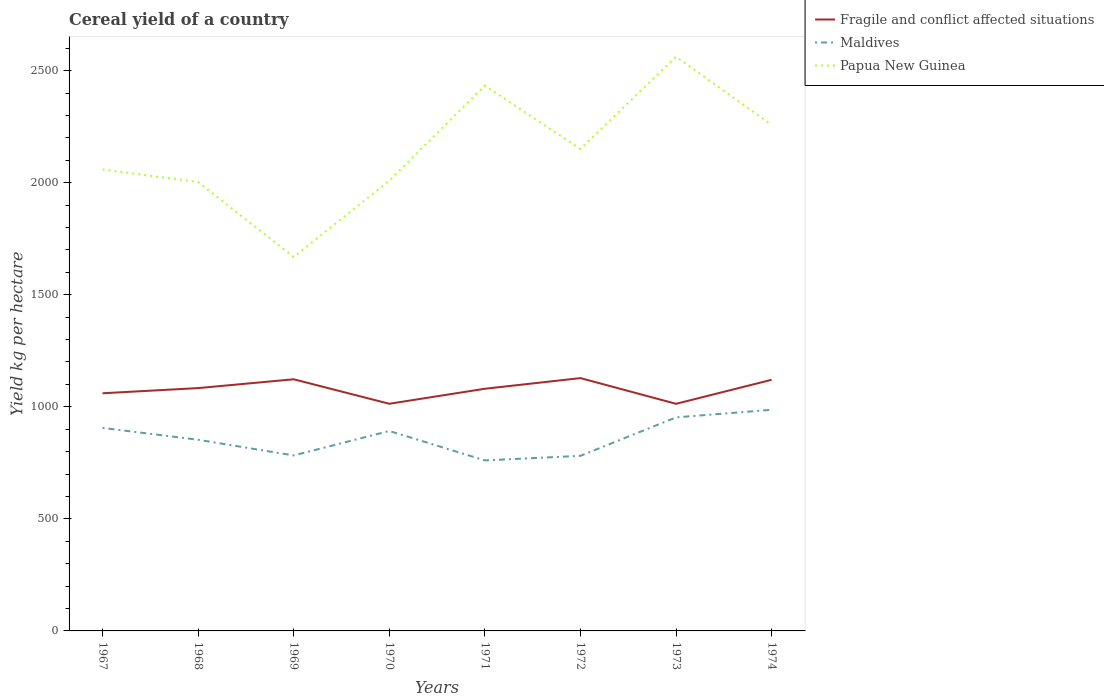Does the line corresponding to Papua New Guinea intersect with the line corresponding to Fragile and conflict affected situations?
Offer a very short reply. No. Across all years, what is the maximum total cereal yield in Papua New Guinea?
Give a very brief answer. 1668.64. In which year was the total cereal yield in Maldives maximum?
Keep it short and to the point. 1971. What is the total total cereal yield in Papua New Guinea in the graph?
Give a very brief answer. -128.69. What is the difference between the highest and the second highest total cereal yield in Maldives?
Keep it short and to the point. 225.92. How many years are there in the graph?
Give a very brief answer. 8. What is the difference between two consecutive major ticks on the Y-axis?
Offer a terse response. 500. Does the graph contain grids?
Give a very brief answer. No. How many legend labels are there?
Make the answer very short. 3. How are the legend labels stacked?
Make the answer very short. Vertical. What is the title of the graph?
Give a very brief answer. Cereal yield of a country. Does "Andorra" appear as one of the legend labels in the graph?
Give a very brief answer. No. What is the label or title of the Y-axis?
Give a very brief answer. Yield kg per hectare. What is the Yield kg per hectare in Fragile and conflict affected situations in 1967?
Offer a terse response. 1060.43. What is the Yield kg per hectare of Maldives in 1967?
Provide a short and direct response. 905.84. What is the Yield kg per hectare of Papua New Guinea in 1967?
Offer a very short reply. 2058.76. What is the Yield kg per hectare in Fragile and conflict affected situations in 1968?
Provide a short and direct response. 1083.5. What is the Yield kg per hectare of Maldives in 1968?
Offer a terse response. 852.94. What is the Yield kg per hectare in Papua New Guinea in 1968?
Your response must be concise. 2003.04. What is the Yield kg per hectare in Fragile and conflict affected situations in 1969?
Make the answer very short. 1122.87. What is the Yield kg per hectare in Maldives in 1969?
Your answer should be very brief. 783.02. What is the Yield kg per hectare of Papua New Guinea in 1969?
Your answer should be compact. 1668.64. What is the Yield kg per hectare of Fragile and conflict affected situations in 1970?
Provide a short and direct response. 1013.57. What is the Yield kg per hectare of Maldives in 1970?
Your answer should be compact. 892.19. What is the Yield kg per hectare of Papua New Guinea in 1970?
Make the answer very short. 2008.81. What is the Yield kg per hectare of Fragile and conflict affected situations in 1971?
Give a very brief answer. 1080.58. What is the Yield kg per hectare in Maldives in 1971?
Provide a short and direct response. 760.87. What is the Yield kg per hectare of Papua New Guinea in 1971?
Provide a succinct answer. 2433.28. What is the Yield kg per hectare of Fragile and conflict affected situations in 1972?
Keep it short and to the point. 1128.12. What is the Yield kg per hectare of Maldives in 1972?
Ensure brevity in your answer.  781.25. What is the Yield kg per hectare in Papua New Guinea in 1972?
Keep it short and to the point. 2150.62. What is the Yield kg per hectare in Fragile and conflict affected situations in 1973?
Offer a terse response. 1013.39. What is the Yield kg per hectare of Maldives in 1973?
Ensure brevity in your answer.  952.79. What is the Yield kg per hectare in Papua New Guinea in 1973?
Ensure brevity in your answer.  2561.97. What is the Yield kg per hectare in Fragile and conflict affected situations in 1974?
Offer a very short reply. 1120.53. What is the Yield kg per hectare in Maldives in 1974?
Give a very brief answer. 986.79. What is the Yield kg per hectare in Papua New Guinea in 1974?
Provide a short and direct response. 2257.98. Across all years, what is the maximum Yield kg per hectare of Fragile and conflict affected situations?
Keep it short and to the point. 1128.12. Across all years, what is the maximum Yield kg per hectare of Maldives?
Offer a terse response. 986.79. Across all years, what is the maximum Yield kg per hectare in Papua New Guinea?
Ensure brevity in your answer.  2561.97. Across all years, what is the minimum Yield kg per hectare of Fragile and conflict affected situations?
Your response must be concise. 1013.39. Across all years, what is the minimum Yield kg per hectare in Maldives?
Provide a short and direct response. 760.87. Across all years, what is the minimum Yield kg per hectare of Papua New Guinea?
Your answer should be compact. 1668.64. What is the total Yield kg per hectare of Fragile and conflict affected situations in the graph?
Offer a terse response. 8622.99. What is the total Yield kg per hectare of Maldives in the graph?
Give a very brief answer. 6915.71. What is the total Yield kg per hectare in Papua New Guinea in the graph?
Offer a terse response. 1.71e+04. What is the difference between the Yield kg per hectare in Fragile and conflict affected situations in 1967 and that in 1968?
Ensure brevity in your answer.  -23.07. What is the difference between the Yield kg per hectare in Maldives in 1967 and that in 1968?
Your answer should be compact. 52.9. What is the difference between the Yield kg per hectare of Papua New Guinea in 1967 and that in 1968?
Offer a terse response. 55.72. What is the difference between the Yield kg per hectare in Fragile and conflict affected situations in 1967 and that in 1969?
Provide a short and direct response. -62.44. What is the difference between the Yield kg per hectare in Maldives in 1967 and that in 1969?
Offer a very short reply. 122.83. What is the difference between the Yield kg per hectare of Papua New Guinea in 1967 and that in 1969?
Offer a very short reply. 390.12. What is the difference between the Yield kg per hectare of Fragile and conflict affected situations in 1967 and that in 1970?
Make the answer very short. 46.86. What is the difference between the Yield kg per hectare in Maldives in 1967 and that in 1970?
Ensure brevity in your answer.  13.65. What is the difference between the Yield kg per hectare of Papua New Guinea in 1967 and that in 1970?
Make the answer very short. 49.95. What is the difference between the Yield kg per hectare of Fragile and conflict affected situations in 1967 and that in 1971?
Make the answer very short. -20.15. What is the difference between the Yield kg per hectare in Maldives in 1967 and that in 1971?
Offer a terse response. 144.97. What is the difference between the Yield kg per hectare of Papua New Guinea in 1967 and that in 1971?
Keep it short and to the point. -374.52. What is the difference between the Yield kg per hectare in Fragile and conflict affected situations in 1967 and that in 1972?
Offer a terse response. -67.69. What is the difference between the Yield kg per hectare of Maldives in 1967 and that in 1972?
Offer a very short reply. 124.59. What is the difference between the Yield kg per hectare of Papua New Guinea in 1967 and that in 1972?
Provide a succinct answer. -91.86. What is the difference between the Yield kg per hectare of Fragile and conflict affected situations in 1967 and that in 1973?
Offer a terse response. 47.04. What is the difference between the Yield kg per hectare of Maldives in 1967 and that in 1973?
Provide a short and direct response. -46.95. What is the difference between the Yield kg per hectare of Papua New Guinea in 1967 and that in 1973?
Offer a very short reply. -503.21. What is the difference between the Yield kg per hectare in Fragile and conflict affected situations in 1967 and that in 1974?
Offer a very short reply. -60.1. What is the difference between the Yield kg per hectare of Maldives in 1967 and that in 1974?
Your answer should be compact. -80.95. What is the difference between the Yield kg per hectare of Papua New Guinea in 1967 and that in 1974?
Provide a succinct answer. -199.22. What is the difference between the Yield kg per hectare of Fragile and conflict affected situations in 1968 and that in 1969?
Make the answer very short. -39.37. What is the difference between the Yield kg per hectare of Maldives in 1968 and that in 1969?
Give a very brief answer. 69.92. What is the difference between the Yield kg per hectare in Papua New Guinea in 1968 and that in 1969?
Your answer should be very brief. 334.4. What is the difference between the Yield kg per hectare in Fragile and conflict affected situations in 1968 and that in 1970?
Ensure brevity in your answer.  69.93. What is the difference between the Yield kg per hectare of Maldives in 1968 and that in 1970?
Your answer should be compact. -39.25. What is the difference between the Yield kg per hectare of Papua New Guinea in 1968 and that in 1970?
Offer a very short reply. -5.77. What is the difference between the Yield kg per hectare of Fragile and conflict affected situations in 1968 and that in 1971?
Give a very brief answer. 2.92. What is the difference between the Yield kg per hectare in Maldives in 1968 and that in 1971?
Your answer should be very brief. 92.07. What is the difference between the Yield kg per hectare of Papua New Guinea in 1968 and that in 1971?
Your response must be concise. -430.24. What is the difference between the Yield kg per hectare of Fragile and conflict affected situations in 1968 and that in 1972?
Make the answer very short. -44.62. What is the difference between the Yield kg per hectare in Maldives in 1968 and that in 1972?
Your answer should be very brief. 71.69. What is the difference between the Yield kg per hectare of Papua New Guinea in 1968 and that in 1972?
Your response must be concise. -147.58. What is the difference between the Yield kg per hectare of Fragile and conflict affected situations in 1968 and that in 1973?
Offer a very short reply. 70.11. What is the difference between the Yield kg per hectare in Maldives in 1968 and that in 1973?
Your response must be concise. -99.85. What is the difference between the Yield kg per hectare in Papua New Guinea in 1968 and that in 1973?
Provide a succinct answer. -558.93. What is the difference between the Yield kg per hectare of Fragile and conflict affected situations in 1968 and that in 1974?
Your response must be concise. -37.03. What is the difference between the Yield kg per hectare of Maldives in 1968 and that in 1974?
Keep it short and to the point. -133.85. What is the difference between the Yield kg per hectare of Papua New Guinea in 1968 and that in 1974?
Make the answer very short. -254.94. What is the difference between the Yield kg per hectare in Fragile and conflict affected situations in 1969 and that in 1970?
Provide a short and direct response. 109.3. What is the difference between the Yield kg per hectare in Maldives in 1969 and that in 1970?
Provide a short and direct response. -109.17. What is the difference between the Yield kg per hectare of Papua New Guinea in 1969 and that in 1970?
Your response must be concise. -340.17. What is the difference between the Yield kg per hectare of Fragile and conflict affected situations in 1969 and that in 1971?
Make the answer very short. 42.28. What is the difference between the Yield kg per hectare of Maldives in 1969 and that in 1971?
Make the answer very short. 22.15. What is the difference between the Yield kg per hectare of Papua New Guinea in 1969 and that in 1971?
Offer a very short reply. -764.63. What is the difference between the Yield kg per hectare in Fragile and conflict affected situations in 1969 and that in 1972?
Provide a short and direct response. -5.25. What is the difference between the Yield kg per hectare in Maldives in 1969 and that in 1972?
Provide a short and direct response. 1.77. What is the difference between the Yield kg per hectare of Papua New Guinea in 1969 and that in 1972?
Give a very brief answer. -481.98. What is the difference between the Yield kg per hectare in Fragile and conflict affected situations in 1969 and that in 1973?
Your response must be concise. 109.48. What is the difference between the Yield kg per hectare in Maldives in 1969 and that in 1973?
Provide a succinct answer. -169.78. What is the difference between the Yield kg per hectare of Papua New Guinea in 1969 and that in 1973?
Ensure brevity in your answer.  -893.33. What is the difference between the Yield kg per hectare of Fragile and conflict affected situations in 1969 and that in 1974?
Give a very brief answer. 2.33. What is the difference between the Yield kg per hectare of Maldives in 1969 and that in 1974?
Offer a terse response. -203.78. What is the difference between the Yield kg per hectare of Papua New Guinea in 1969 and that in 1974?
Offer a very short reply. -589.33. What is the difference between the Yield kg per hectare in Fragile and conflict affected situations in 1970 and that in 1971?
Make the answer very short. -67.01. What is the difference between the Yield kg per hectare in Maldives in 1970 and that in 1971?
Provide a short and direct response. 131.32. What is the difference between the Yield kg per hectare in Papua New Guinea in 1970 and that in 1971?
Your response must be concise. -424.46. What is the difference between the Yield kg per hectare in Fragile and conflict affected situations in 1970 and that in 1972?
Keep it short and to the point. -114.55. What is the difference between the Yield kg per hectare of Maldives in 1970 and that in 1972?
Your response must be concise. 110.94. What is the difference between the Yield kg per hectare in Papua New Guinea in 1970 and that in 1972?
Provide a succinct answer. -141.81. What is the difference between the Yield kg per hectare in Fragile and conflict affected situations in 1970 and that in 1973?
Offer a terse response. 0.18. What is the difference between the Yield kg per hectare of Maldives in 1970 and that in 1973?
Keep it short and to the point. -60.6. What is the difference between the Yield kg per hectare in Papua New Guinea in 1970 and that in 1973?
Your answer should be compact. -553.15. What is the difference between the Yield kg per hectare in Fragile and conflict affected situations in 1970 and that in 1974?
Offer a terse response. -106.96. What is the difference between the Yield kg per hectare of Maldives in 1970 and that in 1974?
Your answer should be compact. -94.6. What is the difference between the Yield kg per hectare of Papua New Guinea in 1970 and that in 1974?
Your answer should be very brief. -249.16. What is the difference between the Yield kg per hectare of Fragile and conflict affected situations in 1971 and that in 1972?
Give a very brief answer. -47.54. What is the difference between the Yield kg per hectare of Maldives in 1971 and that in 1972?
Offer a very short reply. -20.38. What is the difference between the Yield kg per hectare in Papua New Guinea in 1971 and that in 1972?
Provide a short and direct response. 282.66. What is the difference between the Yield kg per hectare of Fragile and conflict affected situations in 1971 and that in 1973?
Offer a terse response. 67.2. What is the difference between the Yield kg per hectare of Maldives in 1971 and that in 1973?
Your response must be concise. -191.93. What is the difference between the Yield kg per hectare of Papua New Guinea in 1971 and that in 1973?
Offer a terse response. -128.69. What is the difference between the Yield kg per hectare of Fragile and conflict affected situations in 1971 and that in 1974?
Ensure brevity in your answer.  -39.95. What is the difference between the Yield kg per hectare in Maldives in 1971 and that in 1974?
Make the answer very short. -225.93. What is the difference between the Yield kg per hectare in Papua New Guinea in 1971 and that in 1974?
Make the answer very short. 175.3. What is the difference between the Yield kg per hectare in Fragile and conflict affected situations in 1972 and that in 1973?
Your response must be concise. 114.73. What is the difference between the Yield kg per hectare in Maldives in 1972 and that in 1973?
Your response must be concise. -171.54. What is the difference between the Yield kg per hectare of Papua New Guinea in 1972 and that in 1973?
Make the answer very short. -411.35. What is the difference between the Yield kg per hectare of Fragile and conflict affected situations in 1972 and that in 1974?
Offer a very short reply. 7.59. What is the difference between the Yield kg per hectare in Maldives in 1972 and that in 1974?
Offer a very short reply. -205.54. What is the difference between the Yield kg per hectare in Papua New Guinea in 1972 and that in 1974?
Your response must be concise. -107.36. What is the difference between the Yield kg per hectare of Fragile and conflict affected situations in 1973 and that in 1974?
Give a very brief answer. -107.15. What is the difference between the Yield kg per hectare of Maldives in 1973 and that in 1974?
Your answer should be compact. -34. What is the difference between the Yield kg per hectare in Papua New Guinea in 1973 and that in 1974?
Your answer should be compact. 303.99. What is the difference between the Yield kg per hectare in Fragile and conflict affected situations in 1967 and the Yield kg per hectare in Maldives in 1968?
Make the answer very short. 207.49. What is the difference between the Yield kg per hectare in Fragile and conflict affected situations in 1967 and the Yield kg per hectare in Papua New Guinea in 1968?
Ensure brevity in your answer.  -942.61. What is the difference between the Yield kg per hectare of Maldives in 1967 and the Yield kg per hectare of Papua New Guinea in 1968?
Your answer should be compact. -1097.2. What is the difference between the Yield kg per hectare of Fragile and conflict affected situations in 1967 and the Yield kg per hectare of Maldives in 1969?
Give a very brief answer. 277.41. What is the difference between the Yield kg per hectare in Fragile and conflict affected situations in 1967 and the Yield kg per hectare in Papua New Guinea in 1969?
Provide a succinct answer. -608.21. What is the difference between the Yield kg per hectare of Maldives in 1967 and the Yield kg per hectare of Papua New Guinea in 1969?
Offer a very short reply. -762.8. What is the difference between the Yield kg per hectare in Fragile and conflict affected situations in 1967 and the Yield kg per hectare in Maldives in 1970?
Your answer should be very brief. 168.24. What is the difference between the Yield kg per hectare in Fragile and conflict affected situations in 1967 and the Yield kg per hectare in Papua New Guinea in 1970?
Provide a short and direct response. -948.39. What is the difference between the Yield kg per hectare in Maldives in 1967 and the Yield kg per hectare in Papua New Guinea in 1970?
Offer a very short reply. -1102.97. What is the difference between the Yield kg per hectare in Fragile and conflict affected situations in 1967 and the Yield kg per hectare in Maldives in 1971?
Provide a short and direct response. 299.56. What is the difference between the Yield kg per hectare in Fragile and conflict affected situations in 1967 and the Yield kg per hectare in Papua New Guinea in 1971?
Provide a succinct answer. -1372.85. What is the difference between the Yield kg per hectare of Maldives in 1967 and the Yield kg per hectare of Papua New Guinea in 1971?
Offer a very short reply. -1527.43. What is the difference between the Yield kg per hectare in Fragile and conflict affected situations in 1967 and the Yield kg per hectare in Maldives in 1972?
Offer a very short reply. 279.18. What is the difference between the Yield kg per hectare in Fragile and conflict affected situations in 1967 and the Yield kg per hectare in Papua New Guinea in 1972?
Your answer should be very brief. -1090.19. What is the difference between the Yield kg per hectare of Maldives in 1967 and the Yield kg per hectare of Papua New Guinea in 1972?
Ensure brevity in your answer.  -1244.78. What is the difference between the Yield kg per hectare of Fragile and conflict affected situations in 1967 and the Yield kg per hectare of Maldives in 1973?
Provide a short and direct response. 107.63. What is the difference between the Yield kg per hectare of Fragile and conflict affected situations in 1967 and the Yield kg per hectare of Papua New Guinea in 1973?
Make the answer very short. -1501.54. What is the difference between the Yield kg per hectare of Maldives in 1967 and the Yield kg per hectare of Papua New Guinea in 1973?
Provide a short and direct response. -1656.12. What is the difference between the Yield kg per hectare of Fragile and conflict affected situations in 1967 and the Yield kg per hectare of Maldives in 1974?
Keep it short and to the point. 73.63. What is the difference between the Yield kg per hectare in Fragile and conflict affected situations in 1967 and the Yield kg per hectare in Papua New Guinea in 1974?
Offer a very short reply. -1197.55. What is the difference between the Yield kg per hectare in Maldives in 1967 and the Yield kg per hectare in Papua New Guinea in 1974?
Keep it short and to the point. -1352.13. What is the difference between the Yield kg per hectare in Fragile and conflict affected situations in 1968 and the Yield kg per hectare in Maldives in 1969?
Offer a very short reply. 300.48. What is the difference between the Yield kg per hectare of Fragile and conflict affected situations in 1968 and the Yield kg per hectare of Papua New Guinea in 1969?
Ensure brevity in your answer.  -585.14. What is the difference between the Yield kg per hectare in Maldives in 1968 and the Yield kg per hectare in Papua New Guinea in 1969?
Your answer should be compact. -815.7. What is the difference between the Yield kg per hectare of Fragile and conflict affected situations in 1968 and the Yield kg per hectare of Maldives in 1970?
Your answer should be compact. 191.31. What is the difference between the Yield kg per hectare in Fragile and conflict affected situations in 1968 and the Yield kg per hectare in Papua New Guinea in 1970?
Ensure brevity in your answer.  -925.31. What is the difference between the Yield kg per hectare of Maldives in 1968 and the Yield kg per hectare of Papua New Guinea in 1970?
Your answer should be compact. -1155.87. What is the difference between the Yield kg per hectare in Fragile and conflict affected situations in 1968 and the Yield kg per hectare in Maldives in 1971?
Make the answer very short. 322.63. What is the difference between the Yield kg per hectare of Fragile and conflict affected situations in 1968 and the Yield kg per hectare of Papua New Guinea in 1971?
Your response must be concise. -1349.78. What is the difference between the Yield kg per hectare in Maldives in 1968 and the Yield kg per hectare in Papua New Guinea in 1971?
Ensure brevity in your answer.  -1580.34. What is the difference between the Yield kg per hectare of Fragile and conflict affected situations in 1968 and the Yield kg per hectare of Maldives in 1972?
Your answer should be compact. 302.25. What is the difference between the Yield kg per hectare in Fragile and conflict affected situations in 1968 and the Yield kg per hectare in Papua New Guinea in 1972?
Provide a succinct answer. -1067.12. What is the difference between the Yield kg per hectare in Maldives in 1968 and the Yield kg per hectare in Papua New Guinea in 1972?
Your answer should be compact. -1297.68. What is the difference between the Yield kg per hectare in Fragile and conflict affected situations in 1968 and the Yield kg per hectare in Maldives in 1973?
Your response must be concise. 130.71. What is the difference between the Yield kg per hectare in Fragile and conflict affected situations in 1968 and the Yield kg per hectare in Papua New Guinea in 1973?
Your answer should be very brief. -1478.47. What is the difference between the Yield kg per hectare in Maldives in 1968 and the Yield kg per hectare in Papua New Guinea in 1973?
Provide a short and direct response. -1709.03. What is the difference between the Yield kg per hectare of Fragile and conflict affected situations in 1968 and the Yield kg per hectare of Maldives in 1974?
Offer a terse response. 96.71. What is the difference between the Yield kg per hectare of Fragile and conflict affected situations in 1968 and the Yield kg per hectare of Papua New Guinea in 1974?
Ensure brevity in your answer.  -1174.47. What is the difference between the Yield kg per hectare in Maldives in 1968 and the Yield kg per hectare in Papua New Guinea in 1974?
Offer a terse response. -1405.04. What is the difference between the Yield kg per hectare in Fragile and conflict affected situations in 1969 and the Yield kg per hectare in Maldives in 1970?
Give a very brief answer. 230.67. What is the difference between the Yield kg per hectare in Fragile and conflict affected situations in 1969 and the Yield kg per hectare in Papua New Guinea in 1970?
Your response must be concise. -885.95. What is the difference between the Yield kg per hectare in Maldives in 1969 and the Yield kg per hectare in Papua New Guinea in 1970?
Provide a short and direct response. -1225.8. What is the difference between the Yield kg per hectare in Fragile and conflict affected situations in 1969 and the Yield kg per hectare in Maldives in 1971?
Provide a succinct answer. 362. What is the difference between the Yield kg per hectare in Fragile and conflict affected situations in 1969 and the Yield kg per hectare in Papua New Guinea in 1971?
Keep it short and to the point. -1310.41. What is the difference between the Yield kg per hectare in Maldives in 1969 and the Yield kg per hectare in Papua New Guinea in 1971?
Offer a very short reply. -1650.26. What is the difference between the Yield kg per hectare in Fragile and conflict affected situations in 1969 and the Yield kg per hectare in Maldives in 1972?
Your response must be concise. 341.62. What is the difference between the Yield kg per hectare in Fragile and conflict affected situations in 1969 and the Yield kg per hectare in Papua New Guinea in 1972?
Make the answer very short. -1027.75. What is the difference between the Yield kg per hectare in Maldives in 1969 and the Yield kg per hectare in Papua New Guinea in 1972?
Offer a very short reply. -1367.6. What is the difference between the Yield kg per hectare in Fragile and conflict affected situations in 1969 and the Yield kg per hectare in Maldives in 1973?
Offer a very short reply. 170.07. What is the difference between the Yield kg per hectare in Fragile and conflict affected situations in 1969 and the Yield kg per hectare in Papua New Guinea in 1973?
Provide a short and direct response. -1439.1. What is the difference between the Yield kg per hectare of Maldives in 1969 and the Yield kg per hectare of Papua New Guinea in 1973?
Provide a short and direct response. -1778.95. What is the difference between the Yield kg per hectare in Fragile and conflict affected situations in 1969 and the Yield kg per hectare in Maldives in 1974?
Your answer should be very brief. 136.07. What is the difference between the Yield kg per hectare in Fragile and conflict affected situations in 1969 and the Yield kg per hectare in Papua New Guinea in 1974?
Offer a terse response. -1135.11. What is the difference between the Yield kg per hectare in Maldives in 1969 and the Yield kg per hectare in Papua New Guinea in 1974?
Your answer should be compact. -1474.96. What is the difference between the Yield kg per hectare of Fragile and conflict affected situations in 1970 and the Yield kg per hectare of Maldives in 1971?
Provide a short and direct response. 252.7. What is the difference between the Yield kg per hectare of Fragile and conflict affected situations in 1970 and the Yield kg per hectare of Papua New Guinea in 1971?
Give a very brief answer. -1419.71. What is the difference between the Yield kg per hectare of Maldives in 1970 and the Yield kg per hectare of Papua New Guinea in 1971?
Make the answer very short. -1541.08. What is the difference between the Yield kg per hectare of Fragile and conflict affected situations in 1970 and the Yield kg per hectare of Maldives in 1972?
Ensure brevity in your answer.  232.32. What is the difference between the Yield kg per hectare of Fragile and conflict affected situations in 1970 and the Yield kg per hectare of Papua New Guinea in 1972?
Your answer should be very brief. -1137.05. What is the difference between the Yield kg per hectare in Maldives in 1970 and the Yield kg per hectare in Papua New Guinea in 1972?
Provide a short and direct response. -1258.43. What is the difference between the Yield kg per hectare in Fragile and conflict affected situations in 1970 and the Yield kg per hectare in Maldives in 1973?
Your answer should be compact. 60.77. What is the difference between the Yield kg per hectare of Fragile and conflict affected situations in 1970 and the Yield kg per hectare of Papua New Guinea in 1973?
Make the answer very short. -1548.4. What is the difference between the Yield kg per hectare of Maldives in 1970 and the Yield kg per hectare of Papua New Guinea in 1973?
Make the answer very short. -1669.78. What is the difference between the Yield kg per hectare of Fragile and conflict affected situations in 1970 and the Yield kg per hectare of Maldives in 1974?
Offer a terse response. 26.77. What is the difference between the Yield kg per hectare of Fragile and conflict affected situations in 1970 and the Yield kg per hectare of Papua New Guinea in 1974?
Offer a very short reply. -1244.41. What is the difference between the Yield kg per hectare in Maldives in 1970 and the Yield kg per hectare in Papua New Guinea in 1974?
Your response must be concise. -1365.78. What is the difference between the Yield kg per hectare of Fragile and conflict affected situations in 1971 and the Yield kg per hectare of Maldives in 1972?
Ensure brevity in your answer.  299.33. What is the difference between the Yield kg per hectare in Fragile and conflict affected situations in 1971 and the Yield kg per hectare in Papua New Guinea in 1972?
Make the answer very short. -1070.04. What is the difference between the Yield kg per hectare of Maldives in 1971 and the Yield kg per hectare of Papua New Guinea in 1972?
Offer a very short reply. -1389.75. What is the difference between the Yield kg per hectare in Fragile and conflict affected situations in 1971 and the Yield kg per hectare in Maldives in 1973?
Give a very brief answer. 127.79. What is the difference between the Yield kg per hectare of Fragile and conflict affected situations in 1971 and the Yield kg per hectare of Papua New Guinea in 1973?
Keep it short and to the point. -1481.38. What is the difference between the Yield kg per hectare of Maldives in 1971 and the Yield kg per hectare of Papua New Guinea in 1973?
Make the answer very short. -1801.1. What is the difference between the Yield kg per hectare of Fragile and conflict affected situations in 1971 and the Yield kg per hectare of Maldives in 1974?
Provide a short and direct response. 93.79. What is the difference between the Yield kg per hectare of Fragile and conflict affected situations in 1971 and the Yield kg per hectare of Papua New Guinea in 1974?
Offer a terse response. -1177.39. What is the difference between the Yield kg per hectare in Maldives in 1971 and the Yield kg per hectare in Papua New Guinea in 1974?
Your answer should be very brief. -1497.11. What is the difference between the Yield kg per hectare of Fragile and conflict affected situations in 1972 and the Yield kg per hectare of Maldives in 1973?
Your response must be concise. 175.32. What is the difference between the Yield kg per hectare in Fragile and conflict affected situations in 1972 and the Yield kg per hectare in Papua New Guinea in 1973?
Give a very brief answer. -1433.85. What is the difference between the Yield kg per hectare in Maldives in 1972 and the Yield kg per hectare in Papua New Guinea in 1973?
Ensure brevity in your answer.  -1780.72. What is the difference between the Yield kg per hectare of Fragile and conflict affected situations in 1972 and the Yield kg per hectare of Maldives in 1974?
Your answer should be very brief. 141.32. What is the difference between the Yield kg per hectare in Fragile and conflict affected situations in 1972 and the Yield kg per hectare in Papua New Guinea in 1974?
Offer a very short reply. -1129.86. What is the difference between the Yield kg per hectare in Maldives in 1972 and the Yield kg per hectare in Papua New Guinea in 1974?
Keep it short and to the point. -1476.73. What is the difference between the Yield kg per hectare of Fragile and conflict affected situations in 1973 and the Yield kg per hectare of Maldives in 1974?
Give a very brief answer. 26.59. What is the difference between the Yield kg per hectare of Fragile and conflict affected situations in 1973 and the Yield kg per hectare of Papua New Guinea in 1974?
Offer a terse response. -1244.59. What is the difference between the Yield kg per hectare in Maldives in 1973 and the Yield kg per hectare in Papua New Guinea in 1974?
Provide a short and direct response. -1305.18. What is the average Yield kg per hectare in Fragile and conflict affected situations per year?
Your answer should be compact. 1077.87. What is the average Yield kg per hectare in Maldives per year?
Your answer should be compact. 864.46. What is the average Yield kg per hectare in Papua New Guinea per year?
Your response must be concise. 2142.89. In the year 1967, what is the difference between the Yield kg per hectare in Fragile and conflict affected situations and Yield kg per hectare in Maldives?
Provide a succinct answer. 154.58. In the year 1967, what is the difference between the Yield kg per hectare in Fragile and conflict affected situations and Yield kg per hectare in Papua New Guinea?
Your response must be concise. -998.33. In the year 1967, what is the difference between the Yield kg per hectare of Maldives and Yield kg per hectare of Papua New Guinea?
Provide a short and direct response. -1152.92. In the year 1968, what is the difference between the Yield kg per hectare of Fragile and conflict affected situations and Yield kg per hectare of Maldives?
Make the answer very short. 230.56. In the year 1968, what is the difference between the Yield kg per hectare in Fragile and conflict affected situations and Yield kg per hectare in Papua New Guinea?
Your answer should be compact. -919.54. In the year 1968, what is the difference between the Yield kg per hectare of Maldives and Yield kg per hectare of Papua New Guinea?
Your answer should be very brief. -1150.1. In the year 1969, what is the difference between the Yield kg per hectare in Fragile and conflict affected situations and Yield kg per hectare in Maldives?
Your answer should be very brief. 339.85. In the year 1969, what is the difference between the Yield kg per hectare in Fragile and conflict affected situations and Yield kg per hectare in Papua New Guinea?
Give a very brief answer. -545.78. In the year 1969, what is the difference between the Yield kg per hectare of Maldives and Yield kg per hectare of Papua New Guinea?
Offer a very short reply. -885.62. In the year 1970, what is the difference between the Yield kg per hectare in Fragile and conflict affected situations and Yield kg per hectare in Maldives?
Offer a terse response. 121.38. In the year 1970, what is the difference between the Yield kg per hectare of Fragile and conflict affected situations and Yield kg per hectare of Papua New Guinea?
Ensure brevity in your answer.  -995.25. In the year 1970, what is the difference between the Yield kg per hectare of Maldives and Yield kg per hectare of Papua New Guinea?
Your answer should be very brief. -1116.62. In the year 1971, what is the difference between the Yield kg per hectare in Fragile and conflict affected situations and Yield kg per hectare in Maldives?
Your answer should be very brief. 319.71. In the year 1971, what is the difference between the Yield kg per hectare in Fragile and conflict affected situations and Yield kg per hectare in Papua New Guinea?
Provide a succinct answer. -1352.69. In the year 1971, what is the difference between the Yield kg per hectare in Maldives and Yield kg per hectare in Papua New Guinea?
Keep it short and to the point. -1672.41. In the year 1972, what is the difference between the Yield kg per hectare of Fragile and conflict affected situations and Yield kg per hectare of Maldives?
Give a very brief answer. 346.87. In the year 1972, what is the difference between the Yield kg per hectare in Fragile and conflict affected situations and Yield kg per hectare in Papua New Guinea?
Offer a terse response. -1022.5. In the year 1972, what is the difference between the Yield kg per hectare in Maldives and Yield kg per hectare in Papua New Guinea?
Provide a succinct answer. -1369.37. In the year 1973, what is the difference between the Yield kg per hectare in Fragile and conflict affected situations and Yield kg per hectare in Maldives?
Your response must be concise. 60.59. In the year 1973, what is the difference between the Yield kg per hectare in Fragile and conflict affected situations and Yield kg per hectare in Papua New Guinea?
Your answer should be very brief. -1548.58. In the year 1973, what is the difference between the Yield kg per hectare of Maldives and Yield kg per hectare of Papua New Guinea?
Give a very brief answer. -1609.17. In the year 1974, what is the difference between the Yield kg per hectare of Fragile and conflict affected situations and Yield kg per hectare of Maldives?
Ensure brevity in your answer.  133.74. In the year 1974, what is the difference between the Yield kg per hectare of Fragile and conflict affected situations and Yield kg per hectare of Papua New Guinea?
Give a very brief answer. -1137.44. In the year 1974, what is the difference between the Yield kg per hectare of Maldives and Yield kg per hectare of Papua New Guinea?
Give a very brief answer. -1271.18. What is the ratio of the Yield kg per hectare of Fragile and conflict affected situations in 1967 to that in 1968?
Provide a short and direct response. 0.98. What is the ratio of the Yield kg per hectare in Maldives in 1967 to that in 1968?
Ensure brevity in your answer.  1.06. What is the ratio of the Yield kg per hectare of Papua New Guinea in 1967 to that in 1968?
Your response must be concise. 1.03. What is the ratio of the Yield kg per hectare of Fragile and conflict affected situations in 1967 to that in 1969?
Offer a very short reply. 0.94. What is the ratio of the Yield kg per hectare in Maldives in 1967 to that in 1969?
Your answer should be very brief. 1.16. What is the ratio of the Yield kg per hectare in Papua New Guinea in 1967 to that in 1969?
Ensure brevity in your answer.  1.23. What is the ratio of the Yield kg per hectare in Fragile and conflict affected situations in 1967 to that in 1970?
Your answer should be very brief. 1.05. What is the ratio of the Yield kg per hectare in Maldives in 1967 to that in 1970?
Keep it short and to the point. 1.02. What is the ratio of the Yield kg per hectare of Papua New Guinea in 1967 to that in 1970?
Your response must be concise. 1.02. What is the ratio of the Yield kg per hectare in Fragile and conflict affected situations in 1967 to that in 1971?
Provide a succinct answer. 0.98. What is the ratio of the Yield kg per hectare of Maldives in 1967 to that in 1971?
Provide a short and direct response. 1.19. What is the ratio of the Yield kg per hectare in Papua New Guinea in 1967 to that in 1971?
Give a very brief answer. 0.85. What is the ratio of the Yield kg per hectare in Maldives in 1967 to that in 1972?
Ensure brevity in your answer.  1.16. What is the ratio of the Yield kg per hectare in Papua New Guinea in 1967 to that in 1972?
Provide a short and direct response. 0.96. What is the ratio of the Yield kg per hectare in Fragile and conflict affected situations in 1967 to that in 1973?
Make the answer very short. 1.05. What is the ratio of the Yield kg per hectare in Maldives in 1967 to that in 1973?
Your response must be concise. 0.95. What is the ratio of the Yield kg per hectare in Papua New Guinea in 1967 to that in 1973?
Offer a terse response. 0.8. What is the ratio of the Yield kg per hectare in Fragile and conflict affected situations in 1967 to that in 1974?
Offer a very short reply. 0.95. What is the ratio of the Yield kg per hectare in Maldives in 1967 to that in 1974?
Ensure brevity in your answer.  0.92. What is the ratio of the Yield kg per hectare of Papua New Guinea in 1967 to that in 1974?
Offer a terse response. 0.91. What is the ratio of the Yield kg per hectare of Fragile and conflict affected situations in 1968 to that in 1969?
Offer a very short reply. 0.96. What is the ratio of the Yield kg per hectare in Maldives in 1968 to that in 1969?
Provide a short and direct response. 1.09. What is the ratio of the Yield kg per hectare of Papua New Guinea in 1968 to that in 1969?
Offer a terse response. 1.2. What is the ratio of the Yield kg per hectare in Fragile and conflict affected situations in 1968 to that in 1970?
Make the answer very short. 1.07. What is the ratio of the Yield kg per hectare of Maldives in 1968 to that in 1970?
Provide a succinct answer. 0.96. What is the ratio of the Yield kg per hectare of Papua New Guinea in 1968 to that in 1970?
Keep it short and to the point. 1. What is the ratio of the Yield kg per hectare of Fragile and conflict affected situations in 1968 to that in 1971?
Ensure brevity in your answer.  1. What is the ratio of the Yield kg per hectare of Maldives in 1968 to that in 1971?
Your response must be concise. 1.12. What is the ratio of the Yield kg per hectare of Papua New Guinea in 1968 to that in 1971?
Your response must be concise. 0.82. What is the ratio of the Yield kg per hectare of Fragile and conflict affected situations in 1968 to that in 1972?
Provide a short and direct response. 0.96. What is the ratio of the Yield kg per hectare in Maldives in 1968 to that in 1972?
Provide a short and direct response. 1.09. What is the ratio of the Yield kg per hectare in Papua New Guinea in 1968 to that in 1972?
Make the answer very short. 0.93. What is the ratio of the Yield kg per hectare in Fragile and conflict affected situations in 1968 to that in 1973?
Make the answer very short. 1.07. What is the ratio of the Yield kg per hectare in Maldives in 1968 to that in 1973?
Your answer should be very brief. 0.9. What is the ratio of the Yield kg per hectare in Papua New Guinea in 1968 to that in 1973?
Give a very brief answer. 0.78. What is the ratio of the Yield kg per hectare of Fragile and conflict affected situations in 1968 to that in 1974?
Provide a succinct answer. 0.97. What is the ratio of the Yield kg per hectare of Maldives in 1968 to that in 1974?
Keep it short and to the point. 0.86. What is the ratio of the Yield kg per hectare of Papua New Guinea in 1968 to that in 1974?
Your answer should be compact. 0.89. What is the ratio of the Yield kg per hectare of Fragile and conflict affected situations in 1969 to that in 1970?
Provide a short and direct response. 1.11. What is the ratio of the Yield kg per hectare in Maldives in 1969 to that in 1970?
Your response must be concise. 0.88. What is the ratio of the Yield kg per hectare in Papua New Guinea in 1969 to that in 1970?
Your answer should be compact. 0.83. What is the ratio of the Yield kg per hectare of Fragile and conflict affected situations in 1969 to that in 1971?
Ensure brevity in your answer.  1.04. What is the ratio of the Yield kg per hectare of Maldives in 1969 to that in 1971?
Keep it short and to the point. 1.03. What is the ratio of the Yield kg per hectare in Papua New Guinea in 1969 to that in 1971?
Offer a terse response. 0.69. What is the ratio of the Yield kg per hectare in Maldives in 1969 to that in 1972?
Ensure brevity in your answer.  1. What is the ratio of the Yield kg per hectare in Papua New Guinea in 1969 to that in 1972?
Provide a short and direct response. 0.78. What is the ratio of the Yield kg per hectare of Fragile and conflict affected situations in 1969 to that in 1973?
Provide a short and direct response. 1.11. What is the ratio of the Yield kg per hectare in Maldives in 1969 to that in 1973?
Provide a succinct answer. 0.82. What is the ratio of the Yield kg per hectare in Papua New Guinea in 1969 to that in 1973?
Give a very brief answer. 0.65. What is the ratio of the Yield kg per hectare of Fragile and conflict affected situations in 1969 to that in 1974?
Your answer should be very brief. 1. What is the ratio of the Yield kg per hectare of Maldives in 1969 to that in 1974?
Give a very brief answer. 0.79. What is the ratio of the Yield kg per hectare in Papua New Guinea in 1969 to that in 1974?
Your response must be concise. 0.74. What is the ratio of the Yield kg per hectare of Fragile and conflict affected situations in 1970 to that in 1971?
Your answer should be very brief. 0.94. What is the ratio of the Yield kg per hectare of Maldives in 1970 to that in 1971?
Provide a succinct answer. 1.17. What is the ratio of the Yield kg per hectare in Papua New Guinea in 1970 to that in 1971?
Offer a terse response. 0.83. What is the ratio of the Yield kg per hectare in Fragile and conflict affected situations in 1970 to that in 1972?
Your response must be concise. 0.9. What is the ratio of the Yield kg per hectare of Maldives in 1970 to that in 1972?
Offer a terse response. 1.14. What is the ratio of the Yield kg per hectare of Papua New Guinea in 1970 to that in 1972?
Offer a terse response. 0.93. What is the ratio of the Yield kg per hectare in Maldives in 1970 to that in 1973?
Ensure brevity in your answer.  0.94. What is the ratio of the Yield kg per hectare of Papua New Guinea in 1970 to that in 1973?
Offer a terse response. 0.78. What is the ratio of the Yield kg per hectare of Fragile and conflict affected situations in 1970 to that in 1974?
Offer a very short reply. 0.9. What is the ratio of the Yield kg per hectare of Maldives in 1970 to that in 1974?
Your answer should be very brief. 0.9. What is the ratio of the Yield kg per hectare in Papua New Guinea in 1970 to that in 1974?
Ensure brevity in your answer.  0.89. What is the ratio of the Yield kg per hectare in Fragile and conflict affected situations in 1971 to that in 1972?
Keep it short and to the point. 0.96. What is the ratio of the Yield kg per hectare of Maldives in 1971 to that in 1972?
Provide a succinct answer. 0.97. What is the ratio of the Yield kg per hectare in Papua New Guinea in 1971 to that in 1972?
Keep it short and to the point. 1.13. What is the ratio of the Yield kg per hectare in Fragile and conflict affected situations in 1971 to that in 1973?
Give a very brief answer. 1.07. What is the ratio of the Yield kg per hectare in Maldives in 1971 to that in 1973?
Your answer should be compact. 0.8. What is the ratio of the Yield kg per hectare in Papua New Guinea in 1971 to that in 1973?
Offer a terse response. 0.95. What is the ratio of the Yield kg per hectare in Fragile and conflict affected situations in 1971 to that in 1974?
Give a very brief answer. 0.96. What is the ratio of the Yield kg per hectare of Maldives in 1971 to that in 1974?
Provide a succinct answer. 0.77. What is the ratio of the Yield kg per hectare of Papua New Guinea in 1971 to that in 1974?
Give a very brief answer. 1.08. What is the ratio of the Yield kg per hectare of Fragile and conflict affected situations in 1972 to that in 1973?
Keep it short and to the point. 1.11. What is the ratio of the Yield kg per hectare of Maldives in 1972 to that in 1973?
Your response must be concise. 0.82. What is the ratio of the Yield kg per hectare of Papua New Guinea in 1972 to that in 1973?
Ensure brevity in your answer.  0.84. What is the ratio of the Yield kg per hectare in Fragile and conflict affected situations in 1972 to that in 1974?
Provide a succinct answer. 1.01. What is the ratio of the Yield kg per hectare of Maldives in 1972 to that in 1974?
Make the answer very short. 0.79. What is the ratio of the Yield kg per hectare of Papua New Guinea in 1972 to that in 1974?
Provide a succinct answer. 0.95. What is the ratio of the Yield kg per hectare of Fragile and conflict affected situations in 1973 to that in 1974?
Make the answer very short. 0.9. What is the ratio of the Yield kg per hectare in Maldives in 1973 to that in 1974?
Your response must be concise. 0.97. What is the ratio of the Yield kg per hectare in Papua New Guinea in 1973 to that in 1974?
Your answer should be compact. 1.13. What is the difference between the highest and the second highest Yield kg per hectare of Fragile and conflict affected situations?
Keep it short and to the point. 5.25. What is the difference between the highest and the second highest Yield kg per hectare in Maldives?
Your response must be concise. 34. What is the difference between the highest and the second highest Yield kg per hectare in Papua New Guinea?
Offer a very short reply. 128.69. What is the difference between the highest and the lowest Yield kg per hectare of Fragile and conflict affected situations?
Ensure brevity in your answer.  114.73. What is the difference between the highest and the lowest Yield kg per hectare in Maldives?
Provide a short and direct response. 225.93. What is the difference between the highest and the lowest Yield kg per hectare in Papua New Guinea?
Your answer should be compact. 893.33. 